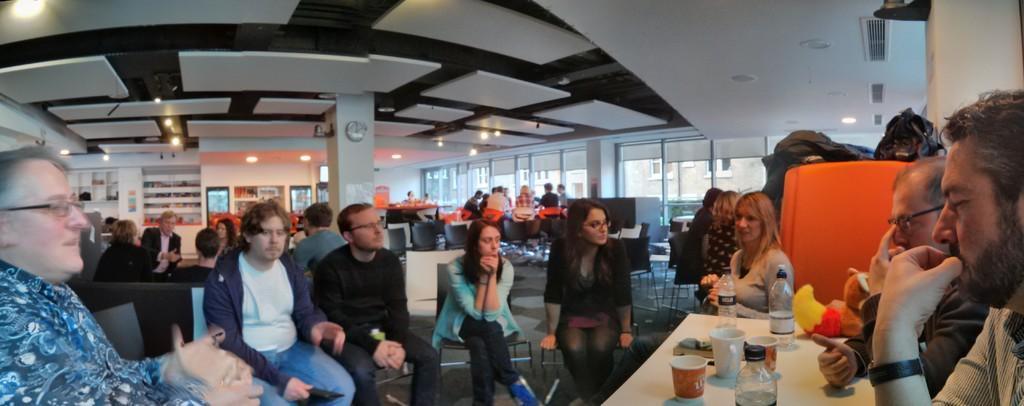In one or two sentences, can you explain what this image depicts? In this picture we can see a group of people sitting on chairs and in front of them on the table we can see bottles, glasses, cup, clock, windows, racks, lights and from windows we can see buildings. 